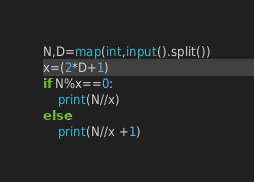Convert code to text. <code><loc_0><loc_0><loc_500><loc_500><_Python_>N,D=map(int,input().split())
x=(2*D+1)
if N%x==0:
    print(N//x)
else:
    print(N//x +1)</code> 